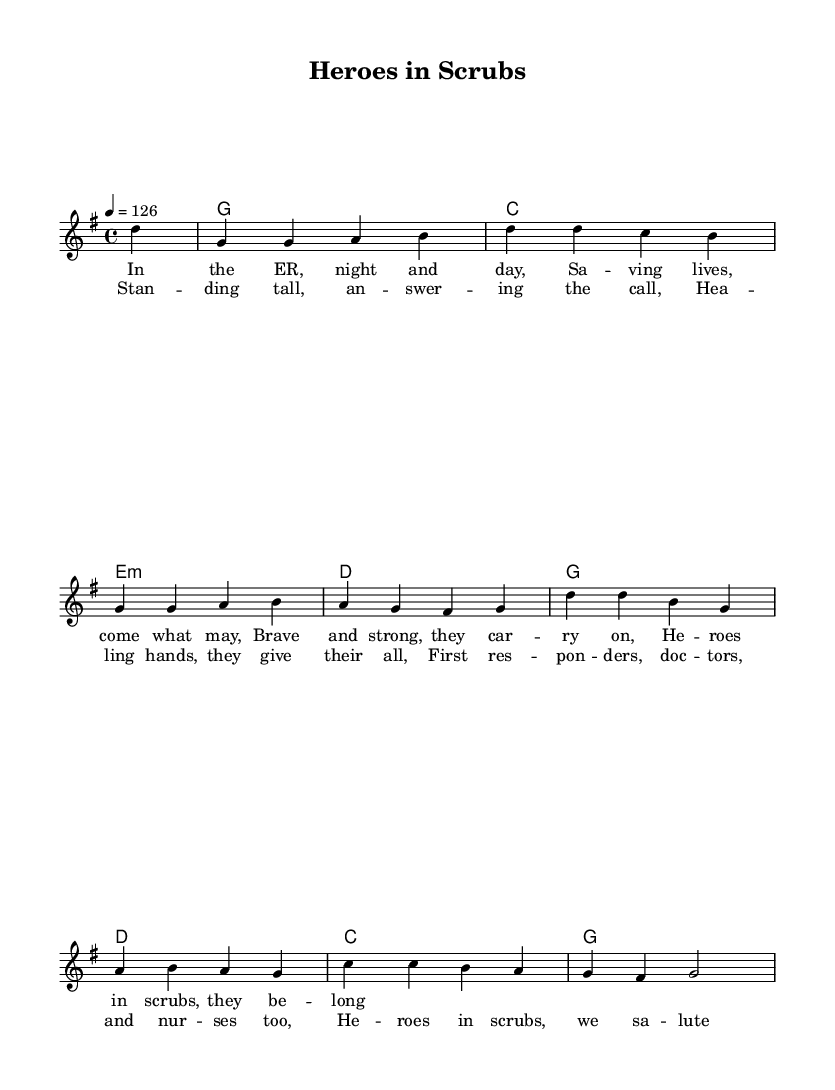What is the key signature of this music? The key signature is G major, indicated by one sharp (F#). This can be observed at the beginning of the staff where the key signature is placed.
Answer: G major What is the time signature of this music? The time signature is 4/4, which means there are four beats in each measure and the quarter note gets one beat. This is shown at the beginning of the staff, right after the key signature.
Answer: 4/4 What is the tempo marking of this piece? The tempo marking indicates a speed of 126 beats per minute. This is specified in the tempo instruction at the beginning of the score.
Answer: 126 How many measures are in the melody? The melody has eight measures. This can be determined by counting the distinct segments between the bar lines in the melody staff.
Answer: Eight What is the main theme of the lyrics? The main theme celebrates first responders and medical professionals as heroes in scrubs. This is evident from the lyrics, which express gratitude and admiration for their bravery and dedication in challenging settings.
Answer: Heroes in scrubs Which chord follows the G chord in the harmony? The chord that follows the G chord in the harmony is C. This information is visible in the chord progression where the G chord is immediately followed by the C chord in the specified sequence.
Answer: C What musical genre does this piece represent? This piece represents the folk genre, specifically upbeat folk-rock anthems, as indicated by the style and content of the lyrics, which celebrate bravery and community service.
Answer: Folk 